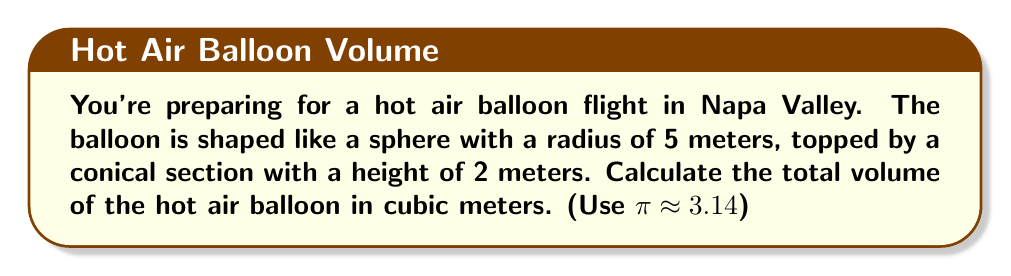What is the answer to this math problem? To calculate the total volume, we need to find the volume of the spherical part and the conical part separately, then add them together.

1. Volume of the sphere:
   The formula for the volume of a sphere is $V_{sphere} = \frac{4}{3}\pi r^3$
   $$V_{sphere} = \frac{4}{3} \cdot 3.14 \cdot 5^3 = \frac{4}{3} \cdot 3.14 \cdot 125 = 523.33 \text{ m}^3$$

2. Volume of the cone:
   The formula for the volume of a cone is $V_{cone} = \frac{1}{3}\pi r^2 h$
   $$V_{cone} = \frac{1}{3} \cdot 3.14 \cdot 5^2 \cdot 2 = \frac{1}{3} \cdot 3.14 \cdot 50 = 52.33 \text{ m}^3$$

3. Total volume:
   Add the volumes of the sphere and cone:
   $$V_{total} = V_{sphere} + V_{cone} = 523.33 + 52.33 = 575.66 \text{ m}^3$$
Answer: $575.66 \text{ m}^3$ 